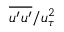Convert formula to latex. <formula><loc_0><loc_0><loc_500><loc_500>{ \overline { { u ^ { \prime } u ^ { \prime } } } } / u _ { \tau } ^ { 2 }</formula> 